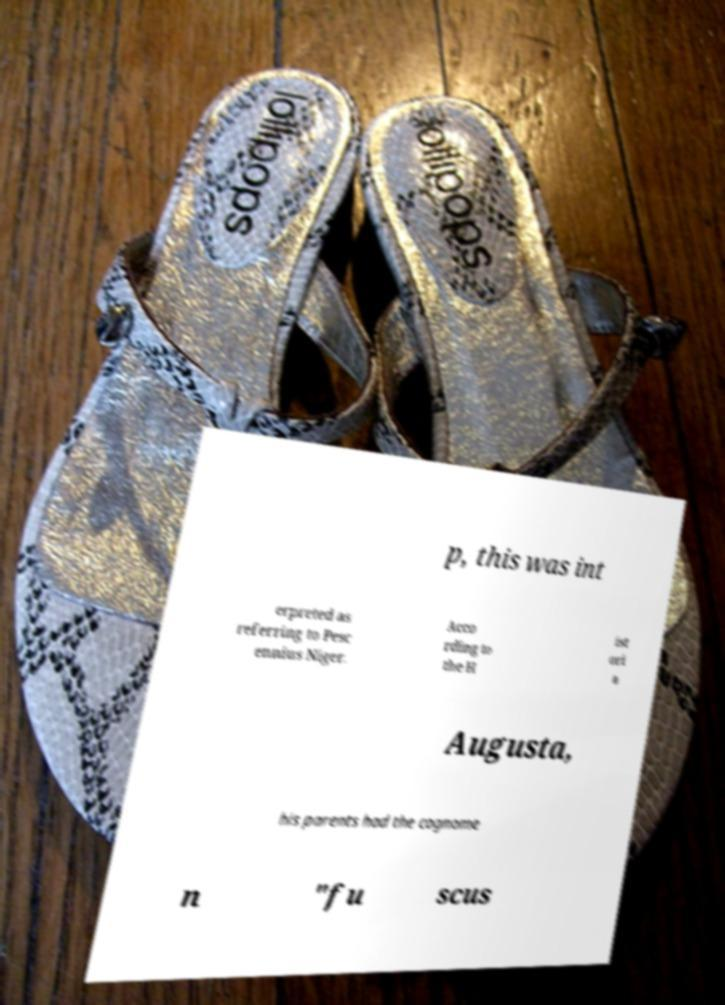Can you accurately transcribe the text from the provided image for me? p, this was int erpreted as referring to Pesc ennius Niger. Acco rding to the H ist ori a Augusta, his parents had the cognome n "fu scus 